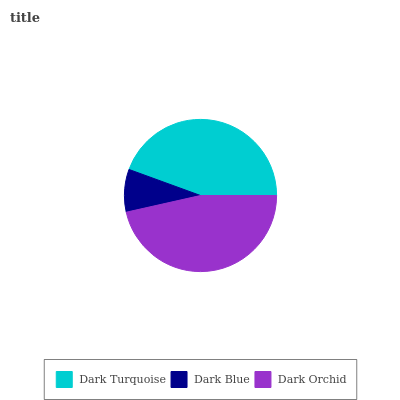Is Dark Blue the minimum?
Answer yes or no. Yes. Is Dark Orchid the maximum?
Answer yes or no. Yes. Is Dark Orchid the minimum?
Answer yes or no. No. Is Dark Blue the maximum?
Answer yes or no. No. Is Dark Orchid greater than Dark Blue?
Answer yes or no. Yes. Is Dark Blue less than Dark Orchid?
Answer yes or no. Yes. Is Dark Blue greater than Dark Orchid?
Answer yes or no. No. Is Dark Orchid less than Dark Blue?
Answer yes or no. No. Is Dark Turquoise the high median?
Answer yes or no. Yes. Is Dark Turquoise the low median?
Answer yes or no. Yes. Is Dark Orchid the high median?
Answer yes or no. No. Is Dark Blue the low median?
Answer yes or no. No. 